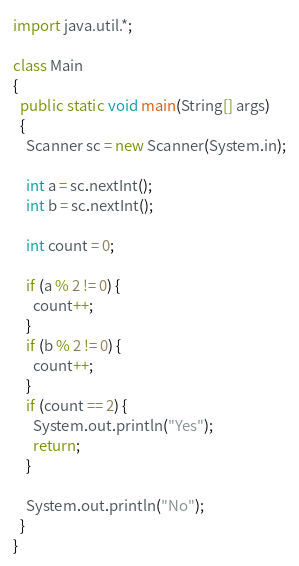Convert code to text. <code><loc_0><loc_0><loc_500><loc_500><_Java_>import java.util.*;

class Main
{
  public static void main(String[] args)
  {
    Scanner sc = new Scanner(System.in);
    
    int a = sc.nextInt();
    int b = sc.nextInt();
    
    int count = 0;
 
    if (a % 2 != 0) {
      count++;
    }
    if (b % 2 != 0) {
      count++;
    }
    if (count == 2) {
      System.out.println("Yes");
      return;
    }
    
    System.out.println("No");
  }
}</code> 